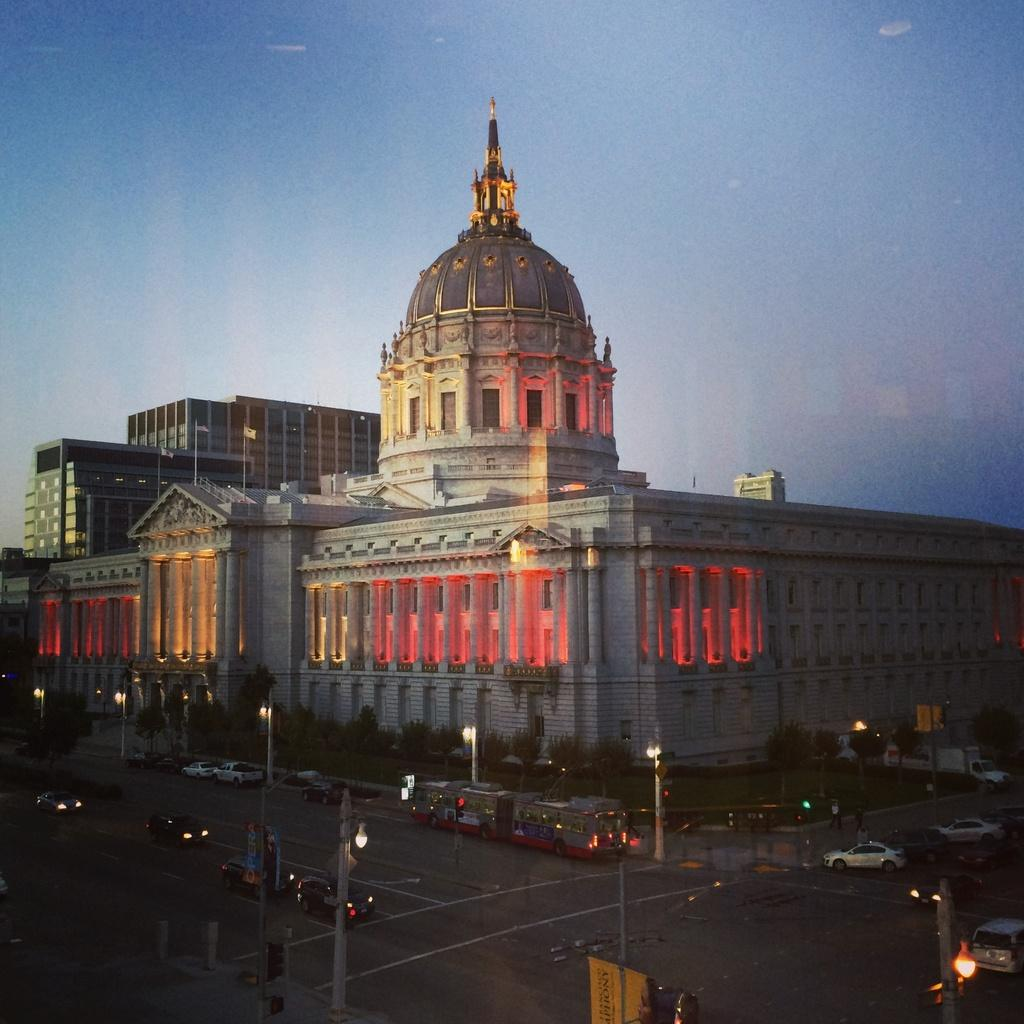What type of location is depicted in the image? The image is of a city. What can be seen on the roads in the image? There are vehicles on the road. What structures are present in the image? There are poles, lights, trees, the United States Capitol, and buildings in the image. What part of the natural environment is visible in the image? Trees are visible in the image. What is visible in the sky in the image? The sky is visible in the image. What type of plot is being developed in the image? There is no plot being developed in the image, as it is a photograph of a city and not a narrative work. What kind of noise can be heard coming from the instruments in the image? There are no instruments present in the image, so it is not possible to determine what kind of noise might be heard. 